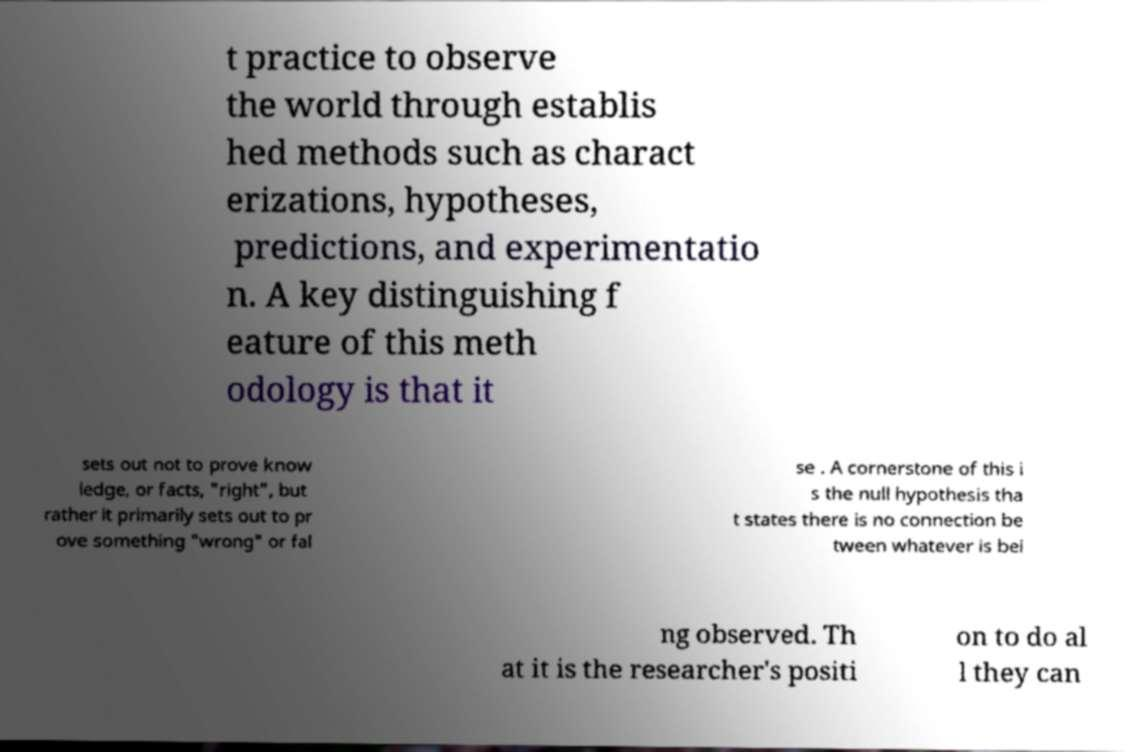Can you accurately transcribe the text from the provided image for me? t practice to observe the world through establis hed methods such as charact erizations, hypotheses, predictions, and experimentatio n. A key distinguishing f eature of this meth odology is that it sets out not to prove know ledge, or facts, "right", but rather it primarily sets out to pr ove something "wrong" or fal se . A cornerstone of this i s the null hypothesis tha t states there is no connection be tween whatever is bei ng observed. Th at it is the researcher's positi on to do al l they can 